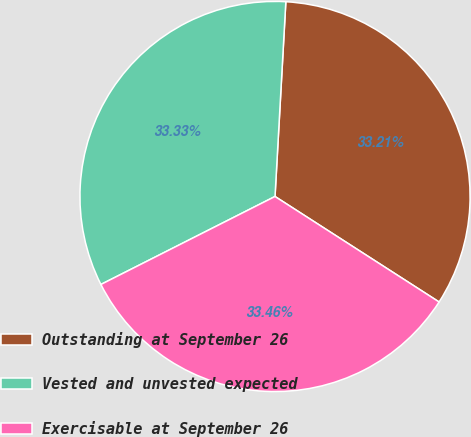<chart> <loc_0><loc_0><loc_500><loc_500><pie_chart><fcel>Outstanding at September 26<fcel>Vested and unvested expected<fcel>Exercisable at September 26<nl><fcel>33.21%<fcel>33.33%<fcel>33.46%<nl></chart> 